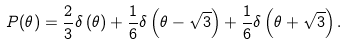<formula> <loc_0><loc_0><loc_500><loc_500>P ( \theta ) = \frac { 2 } { 3 } \delta \left ( \theta \right ) + \frac { 1 } { 6 } \delta \left ( \theta - \sqrt { 3 } \right ) + \frac { 1 } { 6 } \delta \left ( \theta + \sqrt { 3 } \right ) .</formula> 